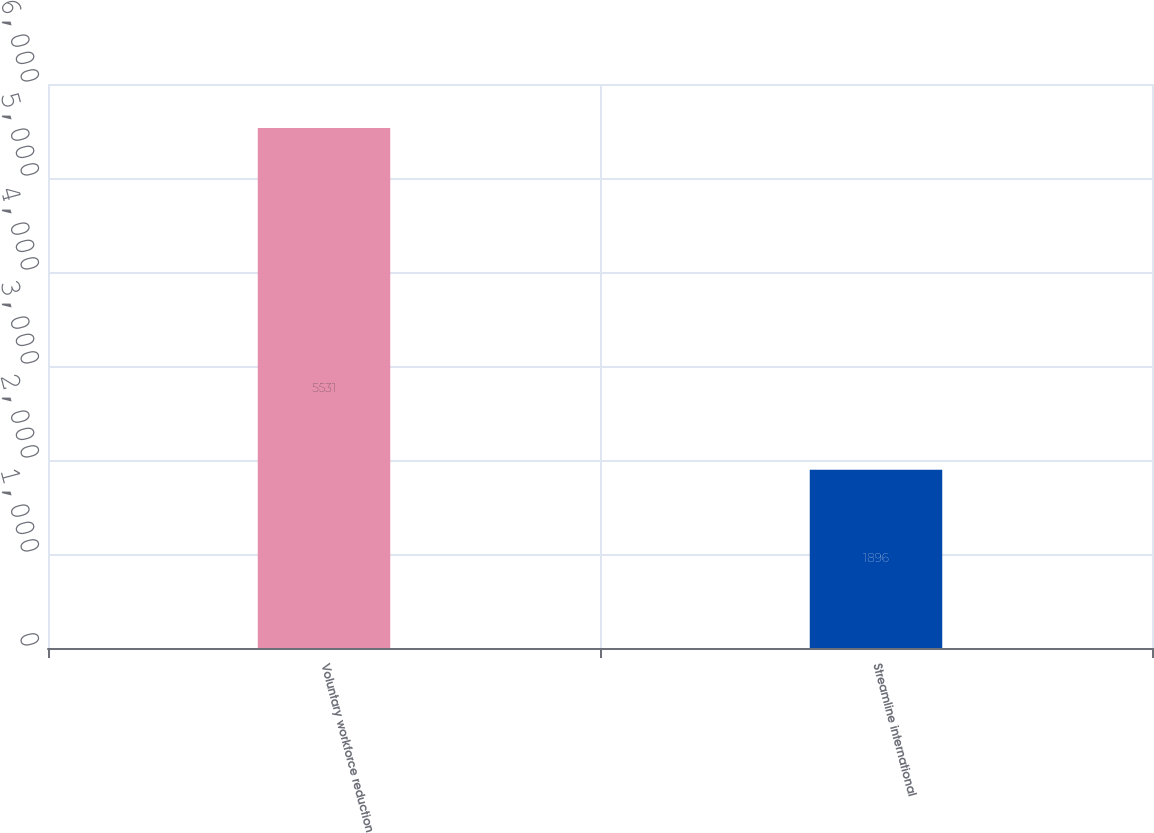Convert chart. <chart><loc_0><loc_0><loc_500><loc_500><bar_chart><fcel>Voluntary workforce reduction<fcel>Streamline international<nl><fcel>5531<fcel>1896<nl></chart> 